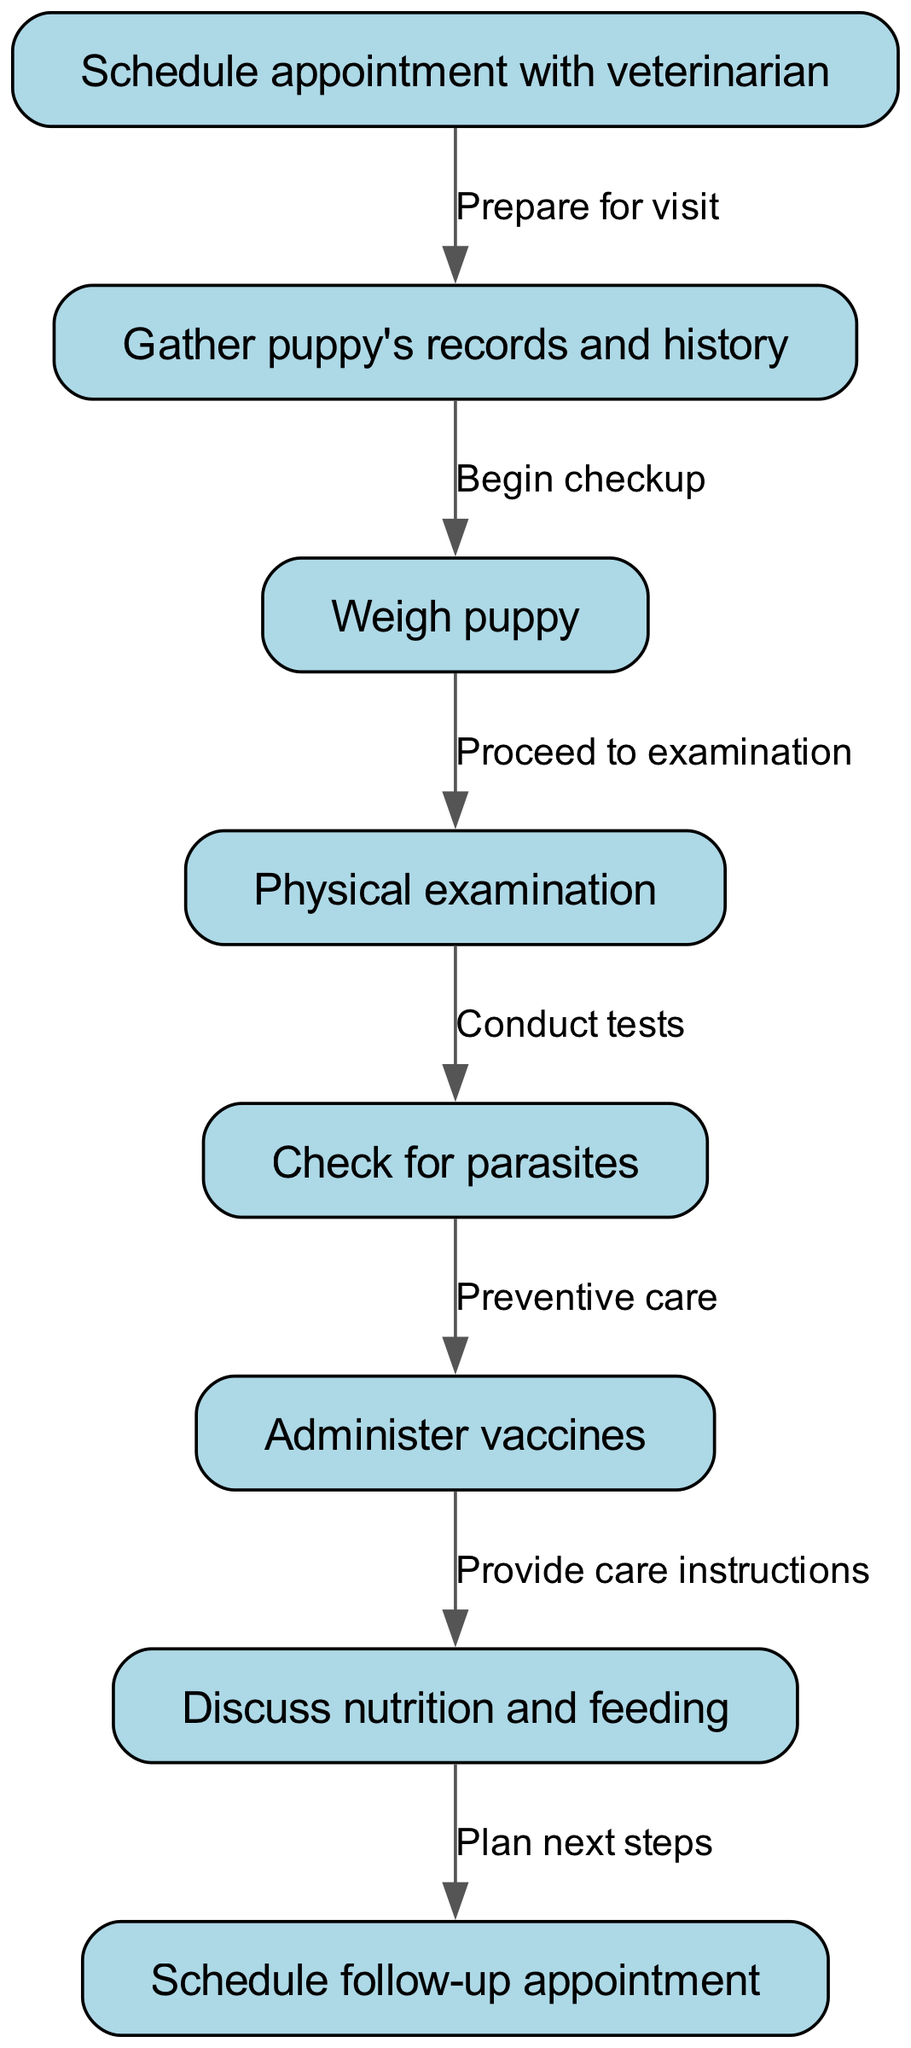What is the first step in the veterinary checkup process? The first node in the diagram indicates that the initial step is to "Schedule appointment with veterinarian." This is the starting point of the clinical pathway.
Answer: Schedule appointment with veterinarian How many nodes are present in the diagram? By counting the individual nodes in the diagram data, we find that there are eight distinct nodes outlining various steps in the checkup process.
Answer: 8 What action follows after weighing the puppy? Weighing the puppy directly leads to the next action, which is a "Physical examination." This shows the sequence in which activities are performed during the checkup.
Answer: Physical examination What is the purpose of administering vaccines? The diagram specifies that the action "Administer vaccines" follows "Check for parasites," indicating that it's part of "Preventive care," ensuring the puppy is protected against diseases.
Answer: Preventive care What is discussed after administering vaccines? After administering vaccines, the next step in the clinical pathway is to "Discuss nutrition and feeding." This indicates that healthcare guidance continues post-vaccination.
Answer: Discuss nutrition and feeding What is the relationship between the nodes "Check for parasites" and "Administer vaccines"? The relationship between these nodes is that after checking for parasites, the action that follows is "Administer vaccines," showing a sequence that emphasizes preventive health measures.
Answer: Preventive care Which step is designated for scheduling the next visit? The last node in the pathway specifies the action to "Schedule follow-up appointment," which outlines the continuity of care for the puppy.
Answer: Schedule follow-up appointment What node precedes the physical examination step? Prior to the physical examination, the previous step, as indicated in the diagram, is "Weigh puppy," establishing the order of operations in the checkup process.
Answer: Weigh puppy 